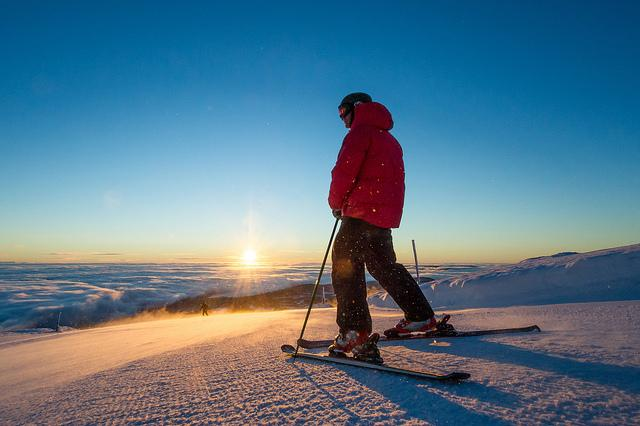Transport using skis to glide on snow is called? skiing 